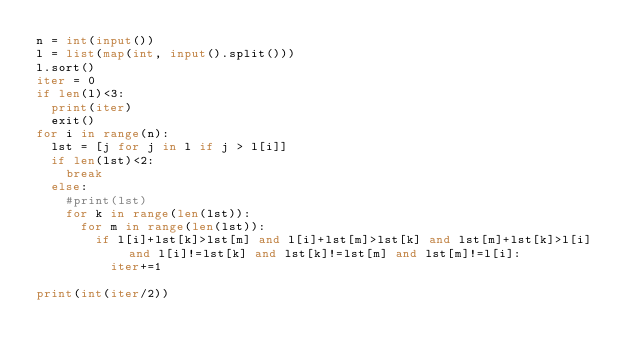Convert code to text. <code><loc_0><loc_0><loc_500><loc_500><_Python_>n = int(input())
l = list(map(int, input().split()))
l.sort()
iter = 0
if len(l)<3:
  print(iter)
  exit()
for i in range(n):
  lst = [j for j in l if j > l[i]]
  if len(lst)<2:
    break
  else:
    #print(lst)
    for k in range(len(lst)):
      for m in range(len(lst)):
        if l[i]+lst[k]>lst[m] and l[i]+lst[m]>lst[k] and lst[m]+lst[k]>l[i] and l[i]!=lst[k] and lst[k]!=lst[m] and lst[m]!=l[i]:
          iter+=1
  
print(int(iter/2))</code> 